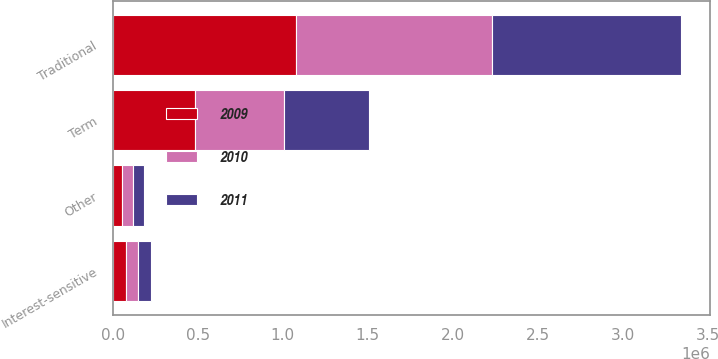Convert chart. <chart><loc_0><loc_0><loc_500><loc_500><stacked_bar_chart><ecel><fcel>Traditional<fcel>Interest-sensitive<fcel>Term<fcel>Other<nl><fcel>2010<fcel>1.15362e+06<fcel>68832<fcel>524784<fcel>66468<nl><fcel>2011<fcel>1.11578e+06<fcel>76248<fcel>499814<fcel>61207<nl><fcel>2009<fcel>1.07735e+06<fcel>80229<fcel>483064<fcel>53762<nl></chart> 